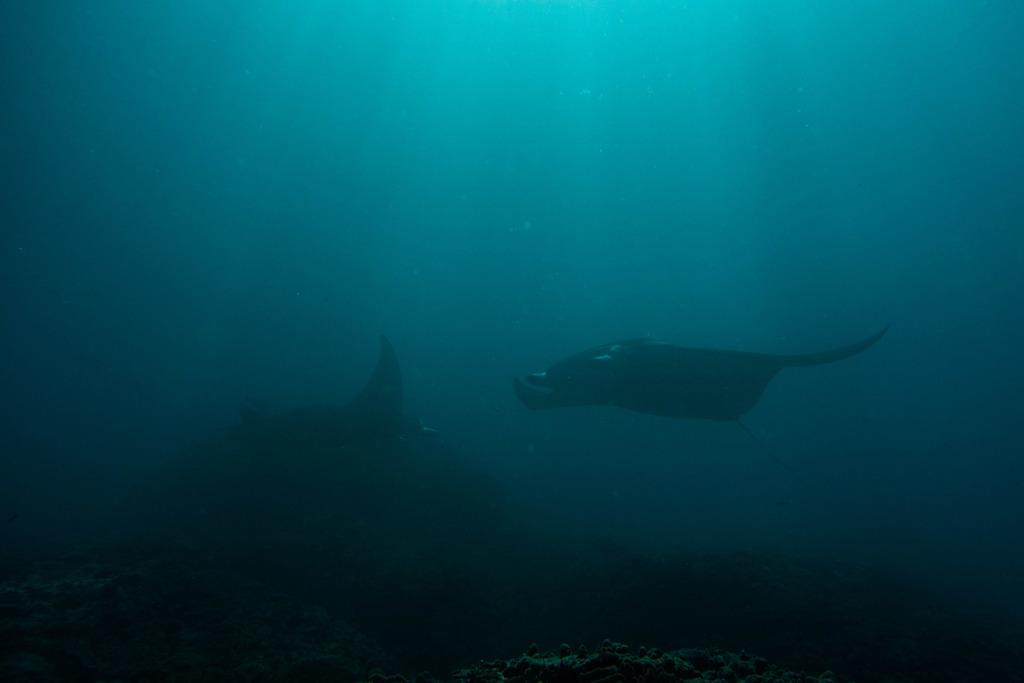What type of animals can be seen in the image? There are marine animals in the image. What else is present in the image besides the marine animals? There are plants in the image. Where are the marine animals and plants located? Both the marine animals and plants are in the water. What type of quill can be seen in the image? There is no quill present in the image; it features marine animals and plants in the water. Is there a stage visible in the image? No, there is no stage present in the image. 